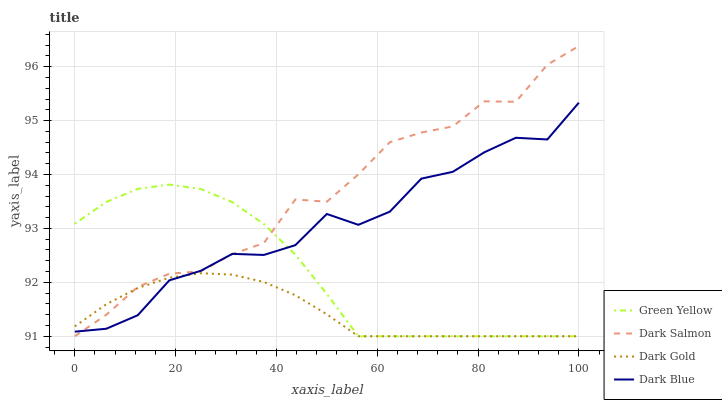Does Dark Gold have the minimum area under the curve?
Answer yes or no. Yes. Does Dark Salmon have the maximum area under the curve?
Answer yes or no. Yes. Does Green Yellow have the minimum area under the curve?
Answer yes or no. No. Does Green Yellow have the maximum area under the curve?
Answer yes or no. No. Is Dark Gold the smoothest?
Answer yes or no. Yes. Is Dark Blue the roughest?
Answer yes or no. Yes. Is Green Yellow the smoothest?
Answer yes or no. No. Is Green Yellow the roughest?
Answer yes or no. No. Does Green Yellow have the highest value?
Answer yes or no. No. 